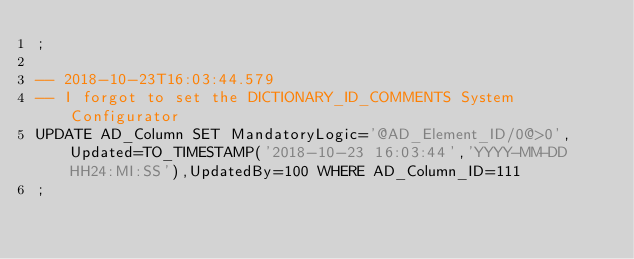<code> <loc_0><loc_0><loc_500><loc_500><_SQL_>;

-- 2018-10-23T16:03:44.579
-- I forgot to set the DICTIONARY_ID_COMMENTS System Configurator
UPDATE AD_Column SET MandatoryLogic='@AD_Element_ID/0@>0',Updated=TO_TIMESTAMP('2018-10-23 16:03:44','YYYY-MM-DD HH24:MI:SS'),UpdatedBy=100 WHERE AD_Column_ID=111
;

</code> 